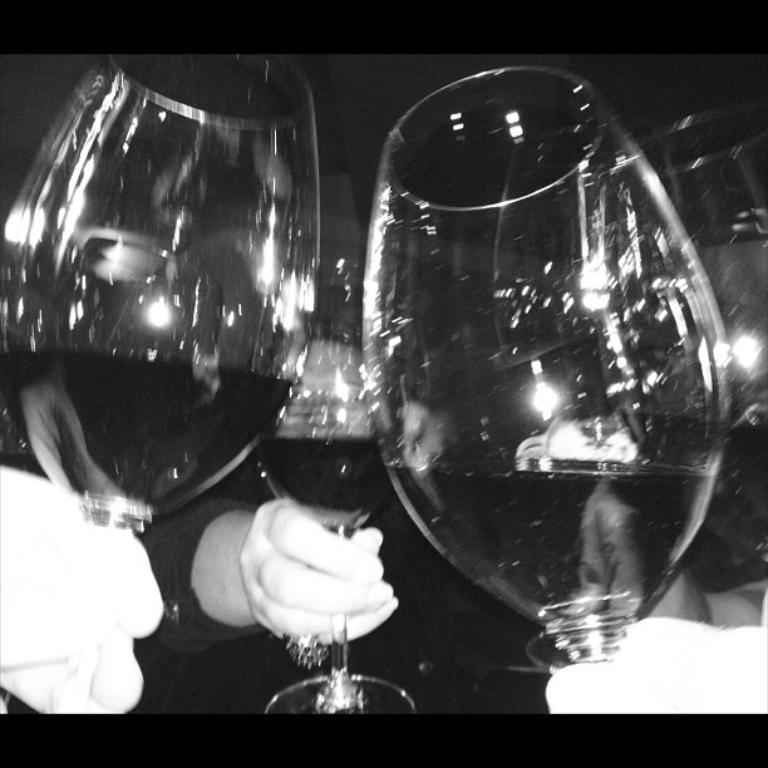What is the color scheme of the images in the picture? The images in the picture are black and white. What are the people holding in the image? The people are holding glasses in the image. What part of the people can be seen in the image? The hands of the people are visible in the image. What type of writing can be seen on the jeans in the image? There are no jeans present in the image, and therefore no writing can be seen on them. 